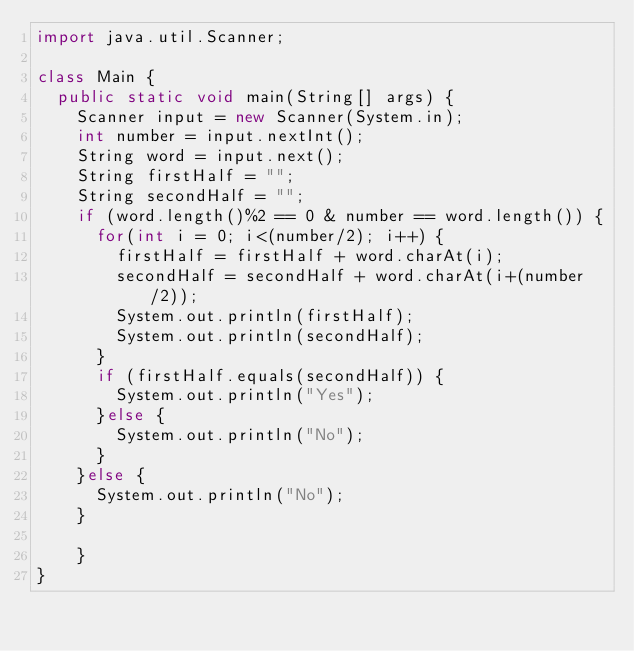<code> <loc_0><loc_0><loc_500><loc_500><_Java_>import java.util.Scanner;

class Main {
	public static void main(String[] args) {
		Scanner input = new Scanner(System.in);
		int number = input.nextInt();
		String word = input.next();
		String firstHalf = "";
		String secondHalf = "";
		if (word.length()%2 == 0 & number == word.length()) {
			for(int i = 0; i<(number/2); i++) {
				firstHalf = firstHalf + word.charAt(i);
				secondHalf = secondHalf + word.charAt(i+(number/2));
				System.out.println(firstHalf); 
				System.out.println(secondHalf); 
			}
			if (firstHalf.equals(secondHalf)) {
				System.out.println("Yes"); 
			}else {
				System.out.println("No"); 
			}
		}else {
			System.out.println("No");   
		}
    	
    }
}
</code> 